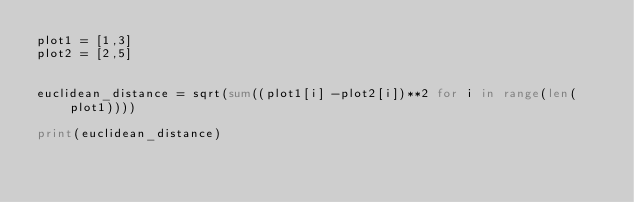Convert code to text. <code><loc_0><loc_0><loc_500><loc_500><_Python_>plot1 = [1,3]
plot2 = [2,5]


euclidean_distance = sqrt(sum((plot1[i] -plot2[i])**2 for i in range(len(plot1))))

print(euclidean_distance)</code> 